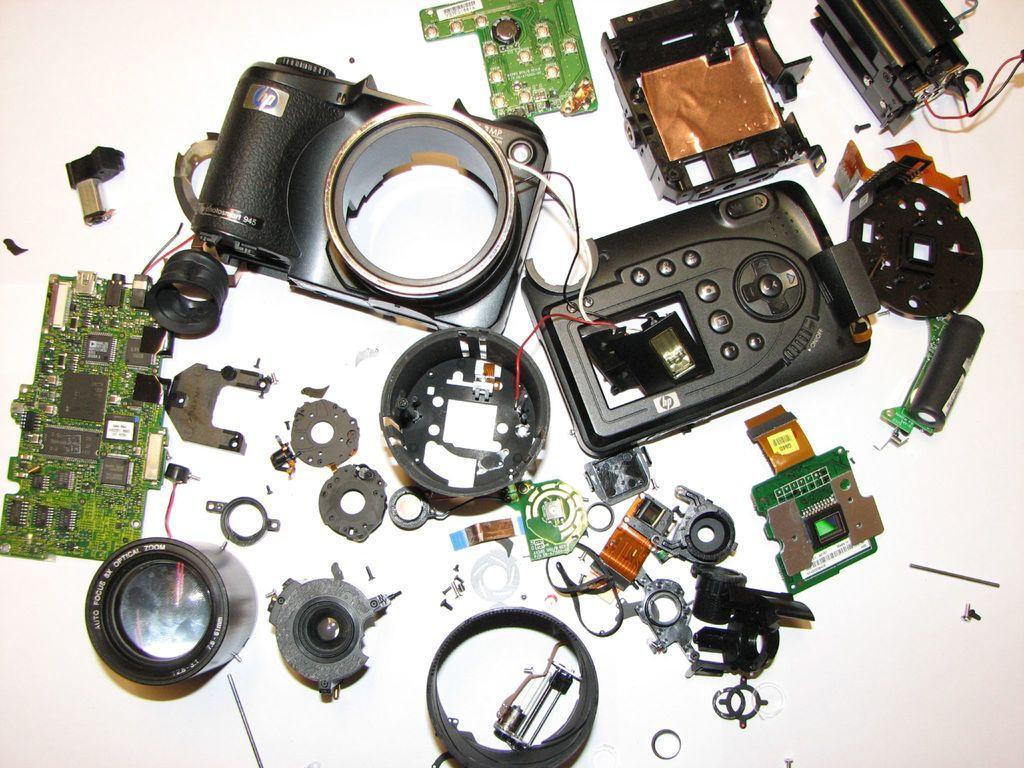Can you describe this image briefly? In the image we can see the parts of camera on a table. 